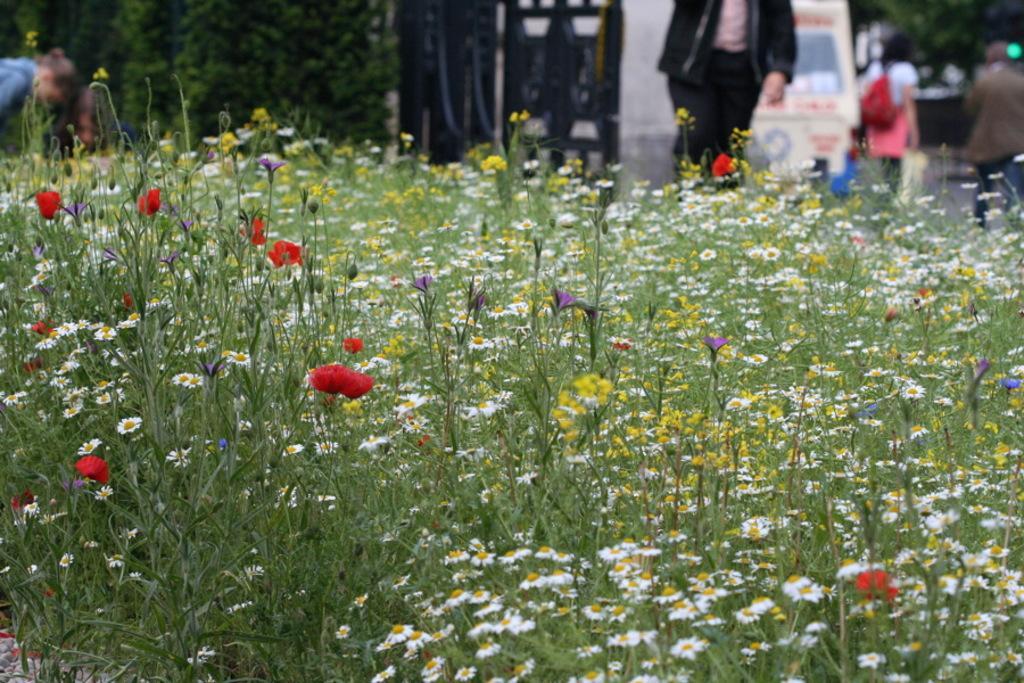Describe this image in one or two sentences. In this image I can see number of flowers and plants in the front. In the background I can see few people, few trees, a white colour thing and I can also see one person is carrying few bag. I can also see this image is little bit blurry in the background. 